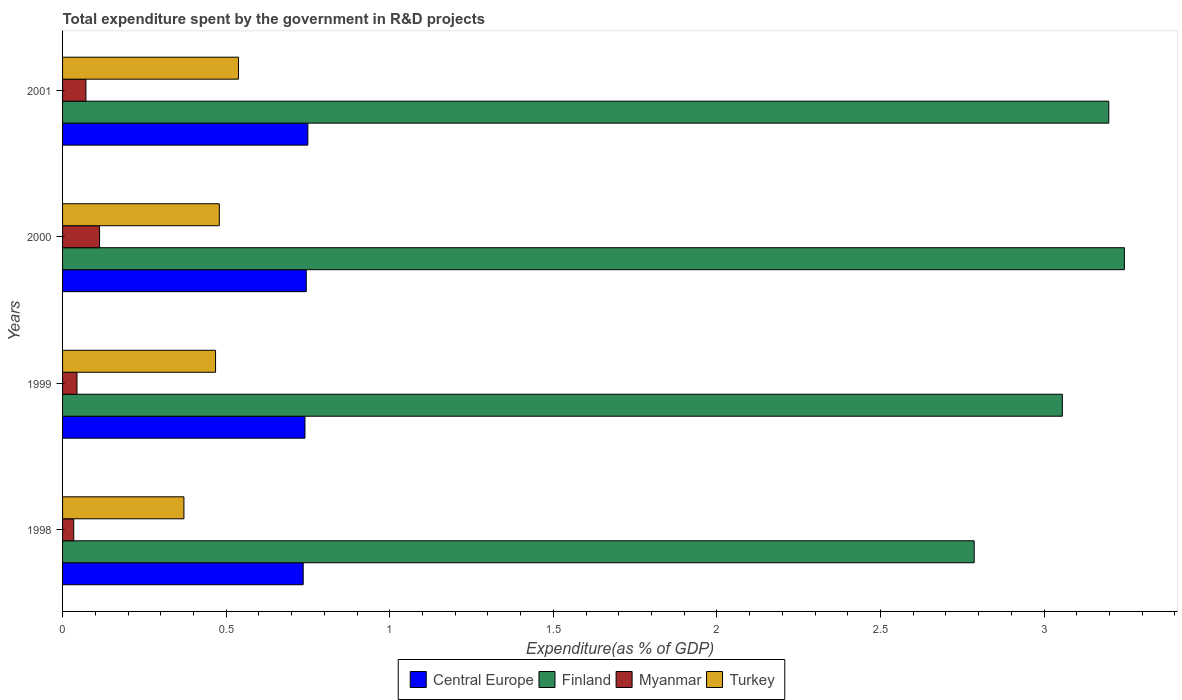Are the number of bars per tick equal to the number of legend labels?
Your answer should be very brief. Yes. How many bars are there on the 4th tick from the top?
Provide a succinct answer. 4. How many bars are there on the 1st tick from the bottom?
Make the answer very short. 4. What is the label of the 3rd group of bars from the top?
Provide a succinct answer. 1999. In how many cases, is the number of bars for a given year not equal to the number of legend labels?
Your answer should be compact. 0. What is the total expenditure spent by the government in R&D projects in Finland in 2000?
Provide a succinct answer. 3.25. Across all years, what is the maximum total expenditure spent by the government in R&D projects in Central Europe?
Offer a very short reply. 0.75. Across all years, what is the minimum total expenditure spent by the government in R&D projects in Turkey?
Ensure brevity in your answer.  0.37. In which year was the total expenditure spent by the government in R&D projects in Turkey maximum?
Your response must be concise. 2001. In which year was the total expenditure spent by the government in R&D projects in Central Europe minimum?
Offer a terse response. 1998. What is the total total expenditure spent by the government in R&D projects in Finland in the graph?
Make the answer very short. 12.29. What is the difference between the total expenditure spent by the government in R&D projects in Turkey in 1998 and that in 2001?
Keep it short and to the point. -0.17. What is the difference between the total expenditure spent by the government in R&D projects in Turkey in 2000 and the total expenditure spent by the government in R&D projects in Central Europe in 1998?
Give a very brief answer. -0.26. What is the average total expenditure spent by the government in R&D projects in Myanmar per year?
Ensure brevity in your answer.  0.07. In the year 1999, what is the difference between the total expenditure spent by the government in R&D projects in Turkey and total expenditure spent by the government in R&D projects in Central Europe?
Make the answer very short. -0.27. What is the ratio of the total expenditure spent by the government in R&D projects in Myanmar in 1998 to that in 1999?
Provide a succinct answer. 0.78. Is the difference between the total expenditure spent by the government in R&D projects in Turkey in 2000 and 2001 greater than the difference between the total expenditure spent by the government in R&D projects in Central Europe in 2000 and 2001?
Offer a very short reply. No. What is the difference between the highest and the second highest total expenditure spent by the government in R&D projects in Finland?
Make the answer very short. 0.05. What is the difference between the highest and the lowest total expenditure spent by the government in R&D projects in Turkey?
Give a very brief answer. 0.17. What does the 3rd bar from the top in 2000 represents?
Make the answer very short. Finland. What does the 3rd bar from the bottom in 2001 represents?
Offer a very short reply. Myanmar. Is it the case that in every year, the sum of the total expenditure spent by the government in R&D projects in Turkey and total expenditure spent by the government in R&D projects in Finland is greater than the total expenditure spent by the government in R&D projects in Myanmar?
Offer a very short reply. Yes. How many years are there in the graph?
Provide a short and direct response. 4. What is the difference between two consecutive major ticks on the X-axis?
Your answer should be very brief. 0.5. Are the values on the major ticks of X-axis written in scientific E-notation?
Offer a very short reply. No. Does the graph contain any zero values?
Make the answer very short. No. Where does the legend appear in the graph?
Give a very brief answer. Bottom center. How many legend labels are there?
Give a very brief answer. 4. What is the title of the graph?
Your response must be concise. Total expenditure spent by the government in R&D projects. What is the label or title of the X-axis?
Provide a short and direct response. Expenditure(as % of GDP). What is the Expenditure(as % of GDP) in Central Europe in 1998?
Your answer should be compact. 0.74. What is the Expenditure(as % of GDP) of Finland in 1998?
Give a very brief answer. 2.79. What is the Expenditure(as % of GDP) in Myanmar in 1998?
Make the answer very short. 0.03. What is the Expenditure(as % of GDP) in Turkey in 1998?
Keep it short and to the point. 0.37. What is the Expenditure(as % of GDP) of Central Europe in 1999?
Your answer should be compact. 0.74. What is the Expenditure(as % of GDP) in Finland in 1999?
Keep it short and to the point. 3.06. What is the Expenditure(as % of GDP) in Myanmar in 1999?
Your response must be concise. 0.04. What is the Expenditure(as % of GDP) in Turkey in 1999?
Your answer should be compact. 0.47. What is the Expenditure(as % of GDP) in Central Europe in 2000?
Offer a terse response. 0.74. What is the Expenditure(as % of GDP) of Finland in 2000?
Make the answer very short. 3.25. What is the Expenditure(as % of GDP) in Myanmar in 2000?
Offer a very short reply. 0.11. What is the Expenditure(as % of GDP) in Turkey in 2000?
Your answer should be very brief. 0.48. What is the Expenditure(as % of GDP) in Central Europe in 2001?
Provide a succinct answer. 0.75. What is the Expenditure(as % of GDP) of Finland in 2001?
Keep it short and to the point. 3.2. What is the Expenditure(as % of GDP) in Myanmar in 2001?
Your answer should be compact. 0.07. What is the Expenditure(as % of GDP) in Turkey in 2001?
Give a very brief answer. 0.54. Across all years, what is the maximum Expenditure(as % of GDP) of Central Europe?
Offer a terse response. 0.75. Across all years, what is the maximum Expenditure(as % of GDP) in Finland?
Provide a succinct answer. 3.25. Across all years, what is the maximum Expenditure(as % of GDP) in Myanmar?
Provide a short and direct response. 0.11. Across all years, what is the maximum Expenditure(as % of GDP) of Turkey?
Ensure brevity in your answer.  0.54. Across all years, what is the minimum Expenditure(as % of GDP) of Central Europe?
Keep it short and to the point. 0.74. Across all years, what is the minimum Expenditure(as % of GDP) in Finland?
Make the answer very short. 2.79. Across all years, what is the minimum Expenditure(as % of GDP) of Myanmar?
Provide a succinct answer. 0.03. Across all years, what is the minimum Expenditure(as % of GDP) in Turkey?
Make the answer very short. 0.37. What is the total Expenditure(as % of GDP) of Central Europe in the graph?
Ensure brevity in your answer.  2.97. What is the total Expenditure(as % of GDP) in Finland in the graph?
Ensure brevity in your answer.  12.29. What is the total Expenditure(as % of GDP) of Myanmar in the graph?
Your answer should be compact. 0.26. What is the total Expenditure(as % of GDP) in Turkey in the graph?
Offer a very short reply. 1.86. What is the difference between the Expenditure(as % of GDP) in Central Europe in 1998 and that in 1999?
Provide a succinct answer. -0.01. What is the difference between the Expenditure(as % of GDP) in Finland in 1998 and that in 1999?
Your response must be concise. -0.27. What is the difference between the Expenditure(as % of GDP) in Myanmar in 1998 and that in 1999?
Offer a terse response. -0.01. What is the difference between the Expenditure(as % of GDP) of Turkey in 1998 and that in 1999?
Your response must be concise. -0.1. What is the difference between the Expenditure(as % of GDP) in Central Europe in 1998 and that in 2000?
Give a very brief answer. -0.01. What is the difference between the Expenditure(as % of GDP) in Finland in 1998 and that in 2000?
Make the answer very short. -0.46. What is the difference between the Expenditure(as % of GDP) in Myanmar in 1998 and that in 2000?
Your answer should be very brief. -0.08. What is the difference between the Expenditure(as % of GDP) in Turkey in 1998 and that in 2000?
Offer a very short reply. -0.11. What is the difference between the Expenditure(as % of GDP) in Central Europe in 1998 and that in 2001?
Your answer should be compact. -0.01. What is the difference between the Expenditure(as % of GDP) in Finland in 1998 and that in 2001?
Provide a short and direct response. -0.41. What is the difference between the Expenditure(as % of GDP) in Myanmar in 1998 and that in 2001?
Make the answer very short. -0.04. What is the difference between the Expenditure(as % of GDP) in Turkey in 1998 and that in 2001?
Ensure brevity in your answer.  -0.17. What is the difference between the Expenditure(as % of GDP) of Central Europe in 1999 and that in 2000?
Provide a short and direct response. -0. What is the difference between the Expenditure(as % of GDP) of Finland in 1999 and that in 2000?
Offer a very short reply. -0.19. What is the difference between the Expenditure(as % of GDP) in Myanmar in 1999 and that in 2000?
Give a very brief answer. -0.07. What is the difference between the Expenditure(as % of GDP) in Turkey in 1999 and that in 2000?
Your response must be concise. -0.01. What is the difference between the Expenditure(as % of GDP) in Central Europe in 1999 and that in 2001?
Offer a very short reply. -0.01. What is the difference between the Expenditure(as % of GDP) of Finland in 1999 and that in 2001?
Provide a short and direct response. -0.14. What is the difference between the Expenditure(as % of GDP) of Myanmar in 1999 and that in 2001?
Your response must be concise. -0.03. What is the difference between the Expenditure(as % of GDP) of Turkey in 1999 and that in 2001?
Make the answer very short. -0.07. What is the difference between the Expenditure(as % of GDP) in Central Europe in 2000 and that in 2001?
Offer a very short reply. -0. What is the difference between the Expenditure(as % of GDP) of Finland in 2000 and that in 2001?
Your response must be concise. 0.05. What is the difference between the Expenditure(as % of GDP) in Myanmar in 2000 and that in 2001?
Give a very brief answer. 0.04. What is the difference between the Expenditure(as % of GDP) of Turkey in 2000 and that in 2001?
Ensure brevity in your answer.  -0.06. What is the difference between the Expenditure(as % of GDP) in Central Europe in 1998 and the Expenditure(as % of GDP) in Finland in 1999?
Offer a terse response. -2.32. What is the difference between the Expenditure(as % of GDP) in Central Europe in 1998 and the Expenditure(as % of GDP) in Myanmar in 1999?
Your response must be concise. 0.69. What is the difference between the Expenditure(as % of GDP) in Central Europe in 1998 and the Expenditure(as % of GDP) in Turkey in 1999?
Your answer should be very brief. 0.27. What is the difference between the Expenditure(as % of GDP) of Finland in 1998 and the Expenditure(as % of GDP) of Myanmar in 1999?
Offer a very short reply. 2.74. What is the difference between the Expenditure(as % of GDP) of Finland in 1998 and the Expenditure(as % of GDP) of Turkey in 1999?
Provide a succinct answer. 2.32. What is the difference between the Expenditure(as % of GDP) in Myanmar in 1998 and the Expenditure(as % of GDP) in Turkey in 1999?
Ensure brevity in your answer.  -0.43. What is the difference between the Expenditure(as % of GDP) in Central Europe in 1998 and the Expenditure(as % of GDP) in Finland in 2000?
Provide a succinct answer. -2.51. What is the difference between the Expenditure(as % of GDP) of Central Europe in 1998 and the Expenditure(as % of GDP) of Myanmar in 2000?
Your response must be concise. 0.62. What is the difference between the Expenditure(as % of GDP) of Central Europe in 1998 and the Expenditure(as % of GDP) of Turkey in 2000?
Make the answer very short. 0.26. What is the difference between the Expenditure(as % of GDP) in Finland in 1998 and the Expenditure(as % of GDP) in Myanmar in 2000?
Your answer should be compact. 2.67. What is the difference between the Expenditure(as % of GDP) in Finland in 1998 and the Expenditure(as % of GDP) in Turkey in 2000?
Provide a short and direct response. 2.31. What is the difference between the Expenditure(as % of GDP) of Myanmar in 1998 and the Expenditure(as % of GDP) of Turkey in 2000?
Your answer should be compact. -0.44. What is the difference between the Expenditure(as % of GDP) of Central Europe in 1998 and the Expenditure(as % of GDP) of Finland in 2001?
Make the answer very short. -2.46. What is the difference between the Expenditure(as % of GDP) in Central Europe in 1998 and the Expenditure(as % of GDP) in Myanmar in 2001?
Make the answer very short. 0.66. What is the difference between the Expenditure(as % of GDP) in Central Europe in 1998 and the Expenditure(as % of GDP) in Turkey in 2001?
Provide a short and direct response. 0.2. What is the difference between the Expenditure(as % of GDP) in Finland in 1998 and the Expenditure(as % of GDP) in Myanmar in 2001?
Give a very brief answer. 2.72. What is the difference between the Expenditure(as % of GDP) of Finland in 1998 and the Expenditure(as % of GDP) of Turkey in 2001?
Give a very brief answer. 2.25. What is the difference between the Expenditure(as % of GDP) of Myanmar in 1998 and the Expenditure(as % of GDP) of Turkey in 2001?
Offer a terse response. -0.5. What is the difference between the Expenditure(as % of GDP) of Central Europe in 1999 and the Expenditure(as % of GDP) of Finland in 2000?
Offer a terse response. -2.5. What is the difference between the Expenditure(as % of GDP) of Central Europe in 1999 and the Expenditure(as % of GDP) of Myanmar in 2000?
Your response must be concise. 0.63. What is the difference between the Expenditure(as % of GDP) in Central Europe in 1999 and the Expenditure(as % of GDP) in Turkey in 2000?
Your response must be concise. 0.26. What is the difference between the Expenditure(as % of GDP) of Finland in 1999 and the Expenditure(as % of GDP) of Myanmar in 2000?
Ensure brevity in your answer.  2.94. What is the difference between the Expenditure(as % of GDP) of Finland in 1999 and the Expenditure(as % of GDP) of Turkey in 2000?
Offer a terse response. 2.58. What is the difference between the Expenditure(as % of GDP) of Myanmar in 1999 and the Expenditure(as % of GDP) of Turkey in 2000?
Offer a terse response. -0.43. What is the difference between the Expenditure(as % of GDP) in Central Europe in 1999 and the Expenditure(as % of GDP) in Finland in 2001?
Provide a succinct answer. -2.46. What is the difference between the Expenditure(as % of GDP) in Central Europe in 1999 and the Expenditure(as % of GDP) in Myanmar in 2001?
Provide a short and direct response. 0.67. What is the difference between the Expenditure(as % of GDP) of Central Europe in 1999 and the Expenditure(as % of GDP) of Turkey in 2001?
Provide a short and direct response. 0.2. What is the difference between the Expenditure(as % of GDP) of Finland in 1999 and the Expenditure(as % of GDP) of Myanmar in 2001?
Ensure brevity in your answer.  2.98. What is the difference between the Expenditure(as % of GDP) in Finland in 1999 and the Expenditure(as % of GDP) in Turkey in 2001?
Your answer should be compact. 2.52. What is the difference between the Expenditure(as % of GDP) in Myanmar in 1999 and the Expenditure(as % of GDP) in Turkey in 2001?
Keep it short and to the point. -0.49. What is the difference between the Expenditure(as % of GDP) in Central Europe in 2000 and the Expenditure(as % of GDP) in Finland in 2001?
Your response must be concise. -2.45. What is the difference between the Expenditure(as % of GDP) of Central Europe in 2000 and the Expenditure(as % of GDP) of Myanmar in 2001?
Provide a short and direct response. 0.67. What is the difference between the Expenditure(as % of GDP) of Central Europe in 2000 and the Expenditure(as % of GDP) of Turkey in 2001?
Provide a short and direct response. 0.21. What is the difference between the Expenditure(as % of GDP) in Finland in 2000 and the Expenditure(as % of GDP) in Myanmar in 2001?
Your answer should be very brief. 3.17. What is the difference between the Expenditure(as % of GDP) of Finland in 2000 and the Expenditure(as % of GDP) of Turkey in 2001?
Give a very brief answer. 2.71. What is the difference between the Expenditure(as % of GDP) of Myanmar in 2000 and the Expenditure(as % of GDP) of Turkey in 2001?
Your answer should be very brief. -0.42. What is the average Expenditure(as % of GDP) of Central Europe per year?
Keep it short and to the point. 0.74. What is the average Expenditure(as % of GDP) of Finland per year?
Provide a succinct answer. 3.07. What is the average Expenditure(as % of GDP) in Myanmar per year?
Give a very brief answer. 0.07. What is the average Expenditure(as % of GDP) of Turkey per year?
Offer a terse response. 0.46. In the year 1998, what is the difference between the Expenditure(as % of GDP) of Central Europe and Expenditure(as % of GDP) of Finland?
Keep it short and to the point. -2.05. In the year 1998, what is the difference between the Expenditure(as % of GDP) in Central Europe and Expenditure(as % of GDP) in Myanmar?
Your answer should be compact. 0.7. In the year 1998, what is the difference between the Expenditure(as % of GDP) in Central Europe and Expenditure(as % of GDP) in Turkey?
Give a very brief answer. 0.36. In the year 1998, what is the difference between the Expenditure(as % of GDP) in Finland and Expenditure(as % of GDP) in Myanmar?
Your answer should be compact. 2.75. In the year 1998, what is the difference between the Expenditure(as % of GDP) of Finland and Expenditure(as % of GDP) of Turkey?
Your answer should be compact. 2.42. In the year 1998, what is the difference between the Expenditure(as % of GDP) of Myanmar and Expenditure(as % of GDP) of Turkey?
Keep it short and to the point. -0.34. In the year 1999, what is the difference between the Expenditure(as % of GDP) of Central Europe and Expenditure(as % of GDP) of Finland?
Give a very brief answer. -2.32. In the year 1999, what is the difference between the Expenditure(as % of GDP) of Central Europe and Expenditure(as % of GDP) of Myanmar?
Your answer should be compact. 0.7. In the year 1999, what is the difference between the Expenditure(as % of GDP) in Central Europe and Expenditure(as % of GDP) in Turkey?
Your answer should be very brief. 0.27. In the year 1999, what is the difference between the Expenditure(as % of GDP) of Finland and Expenditure(as % of GDP) of Myanmar?
Give a very brief answer. 3.01. In the year 1999, what is the difference between the Expenditure(as % of GDP) of Finland and Expenditure(as % of GDP) of Turkey?
Keep it short and to the point. 2.59. In the year 1999, what is the difference between the Expenditure(as % of GDP) in Myanmar and Expenditure(as % of GDP) in Turkey?
Your answer should be compact. -0.42. In the year 2000, what is the difference between the Expenditure(as % of GDP) of Central Europe and Expenditure(as % of GDP) of Finland?
Provide a short and direct response. -2.5. In the year 2000, what is the difference between the Expenditure(as % of GDP) of Central Europe and Expenditure(as % of GDP) of Myanmar?
Provide a short and direct response. 0.63. In the year 2000, what is the difference between the Expenditure(as % of GDP) in Central Europe and Expenditure(as % of GDP) in Turkey?
Provide a short and direct response. 0.27. In the year 2000, what is the difference between the Expenditure(as % of GDP) in Finland and Expenditure(as % of GDP) in Myanmar?
Provide a short and direct response. 3.13. In the year 2000, what is the difference between the Expenditure(as % of GDP) in Finland and Expenditure(as % of GDP) in Turkey?
Your response must be concise. 2.77. In the year 2000, what is the difference between the Expenditure(as % of GDP) in Myanmar and Expenditure(as % of GDP) in Turkey?
Offer a terse response. -0.37. In the year 2001, what is the difference between the Expenditure(as % of GDP) of Central Europe and Expenditure(as % of GDP) of Finland?
Give a very brief answer. -2.45. In the year 2001, what is the difference between the Expenditure(as % of GDP) of Central Europe and Expenditure(as % of GDP) of Myanmar?
Offer a very short reply. 0.68. In the year 2001, what is the difference between the Expenditure(as % of GDP) in Central Europe and Expenditure(as % of GDP) in Turkey?
Keep it short and to the point. 0.21. In the year 2001, what is the difference between the Expenditure(as % of GDP) of Finland and Expenditure(as % of GDP) of Myanmar?
Give a very brief answer. 3.13. In the year 2001, what is the difference between the Expenditure(as % of GDP) of Finland and Expenditure(as % of GDP) of Turkey?
Ensure brevity in your answer.  2.66. In the year 2001, what is the difference between the Expenditure(as % of GDP) of Myanmar and Expenditure(as % of GDP) of Turkey?
Provide a succinct answer. -0.47. What is the ratio of the Expenditure(as % of GDP) in Central Europe in 1998 to that in 1999?
Your response must be concise. 0.99. What is the ratio of the Expenditure(as % of GDP) in Finland in 1998 to that in 1999?
Make the answer very short. 0.91. What is the ratio of the Expenditure(as % of GDP) of Myanmar in 1998 to that in 1999?
Offer a terse response. 0.78. What is the ratio of the Expenditure(as % of GDP) in Turkey in 1998 to that in 1999?
Give a very brief answer. 0.79. What is the ratio of the Expenditure(as % of GDP) of Central Europe in 1998 to that in 2000?
Your answer should be very brief. 0.99. What is the ratio of the Expenditure(as % of GDP) in Finland in 1998 to that in 2000?
Your answer should be compact. 0.86. What is the ratio of the Expenditure(as % of GDP) of Myanmar in 1998 to that in 2000?
Your answer should be very brief. 0.3. What is the ratio of the Expenditure(as % of GDP) in Turkey in 1998 to that in 2000?
Your answer should be compact. 0.77. What is the ratio of the Expenditure(as % of GDP) of Finland in 1998 to that in 2001?
Your response must be concise. 0.87. What is the ratio of the Expenditure(as % of GDP) of Myanmar in 1998 to that in 2001?
Give a very brief answer. 0.48. What is the ratio of the Expenditure(as % of GDP) of Turkey in 1998 to that in 2001?
Give a very brief answer. 0.69. What is the ratio of the Expenditure(as % of GDP) of Central Europe in 1999 to that in 2000?
Make the answer very short. 0.99. What is the ratio of the Expenditure(as % of GDP) of Finland in 1999 to that in 2000?
Your answer should be compact. 0.94. What is the ratio of the Expenditure(as % of GDP) of Myanmar in 1999 to that in 2000?
Your answer should be very brief. 0.39. What is the ratio of the Expenditure(as % of GDP) of Turkey in 1999 to that in 2000?
Provide a short and direct response. 0.98. What is the ratio of the Expenditure(as % of GDP) in Central Europe in 1999 to that in 2001?
Provide a succinct answer. 0.99. What is the ratio of the Expenditure(as % of GDP) in Finland in 1999 to that in 2001?
Your answer should be compact. 0.96. What is the ratio of the Expenditure(as % of GDP) in Myanmar in 1999 to that in 2001?
Provide a succinct answer. 0.62. What is the ratio of the Expenditure(as % of GDP) in Turkey in 1999 to that in 2001?
Provide a short and direct response. 0.87. What is the ratio of the Expenditure(as % of GDP) of Central Europe in 2000 to that in 2001?
Provide a succinct answer. 0.99. What is the ratio of the Expenditure(as % of GDP) in Finland in 2000 to that in 2001?
Ensure brevity in your answer.  1.01. What is the ratio of the Expenditure(as % of GDP) of Myanmar in 2000 to that in 2001?
Provide a succinct answer. 1.58. What is the ratio of the Expenditure(as % of GDP) in Turkey in 2000 to that in 2001?
Ensure brevity in your answer.  0.89. What is the difference between the highest and the second highest Expenditure(as % of GDP) of Central Europe?
Your answer should be compact. 0. What is the difference between the highest and the second highest Expenditure(as % of GDP) of Finland?
Keep it short and to the point. 0.05. What is the difference between the highest and the second highest Expenditure(as % of GDP) in Myanmar?
Provide a short and direct response. 0.04. What is the difference between the highest and the second highest Expenditure(as % of GDP) of Turkey?
Offer a terse response. 0.06. What is the difference between the highest and the lowest Expenditure(as % of GDP) of Central Europe?
Provide a succinct answer. 0.01. What is the difference between the highest and the lowest Expenditure(as % of GDP) in Finland?
Provide a succinct answer. 0.46. What is the difference between the highest and the lowest Expenditure(as % of GDP) in Myanmar?
Your answer should be compact. 0.08. What is the difference between the highest and the lowest Expenditure(as % of GDP) of Turkey?
Give a very brief answer. 0.17. 